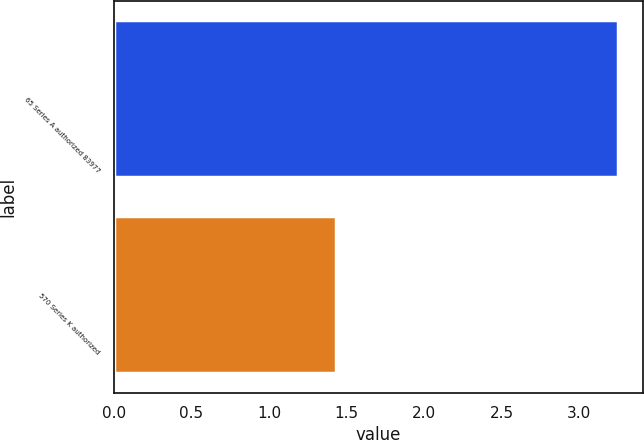Convert chart to OTSL. <chart><loc_0><loc_0><loc_500><loc_500><bar_chart><fcel>65 Series A authorized 83977<fcel>570 Series K authorized<nl><fcel>3.25<fcel>1.43<nl></chart> 